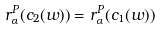<formula> <loc_0><loc_0><loc_500><loc_500>r _ { \alpha } ^ { P } ( c _ { 2 } ( w ) ) = r _ { \alpha } ^ { P } ( c _ { 1 } ( w ) )</formula> 